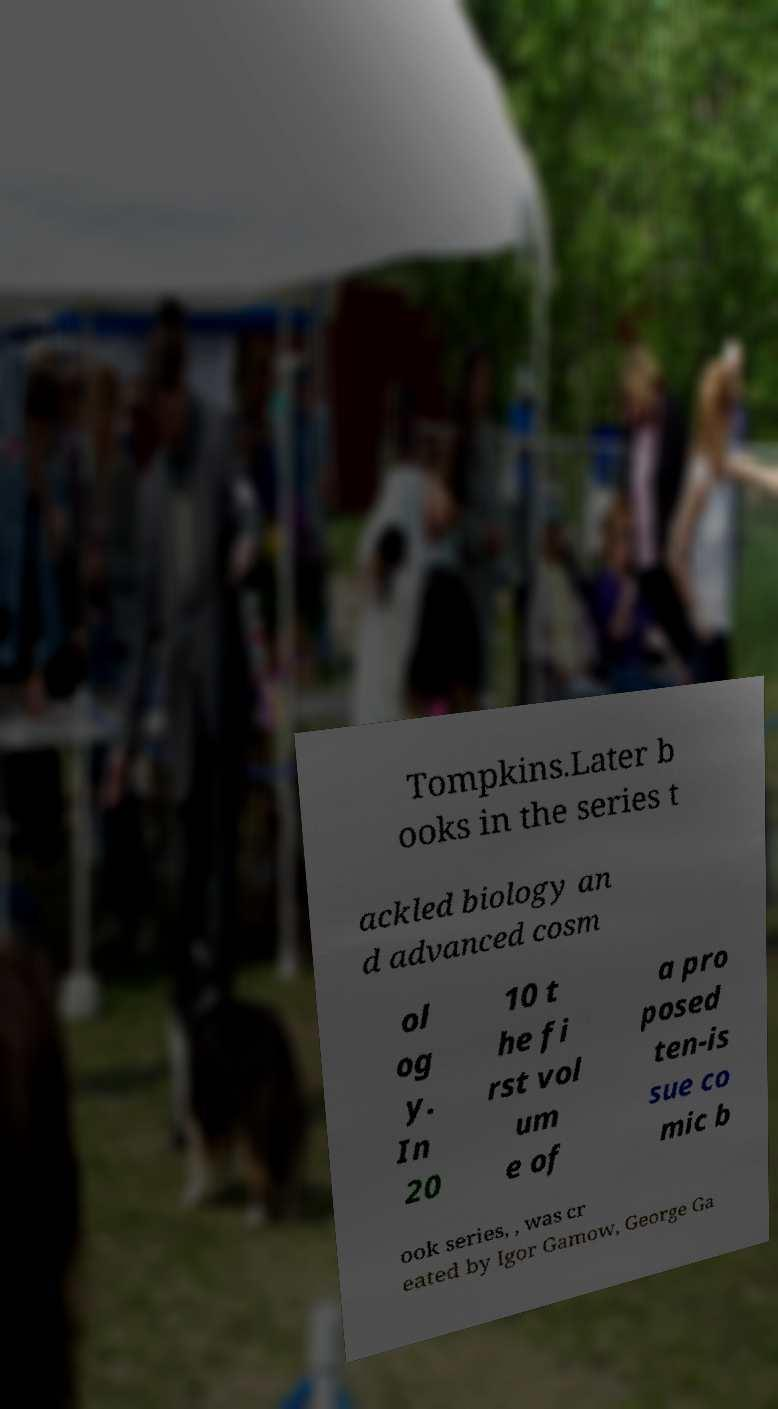I need the written content from this picture converted into text. Can you do that? Tompkins.Later b ooks in the series t ackled biology an d advanced cosm ol og y. In 20 10 t he fi rst vol um e of a pro posed ten-is sue co mic b ook series, , was cr eated by Igor Gamow, George Ga 